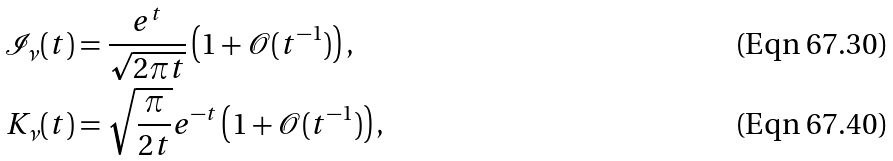Convert formula to latex. <formula><loc_0><loc_0><loc_500><loc_500>\mathcal { I } _ { \nu } ( t ) & = \frac { e ^ { t } } { \sqrt { 2 \pi t } } \left ( 1 + \mathcal { O } ( t ^ { - 1 } ) \right ) , \\ K _ { \nu } ( t ) & = \sqrt { \frac { \pi } { 2 t } } e ^ { - t } \left ( 1 + \mathcal { O } ( t ^ { - 1 } ) \right ) ,</formula> 